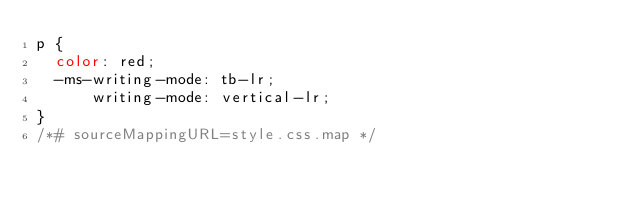Convert code to text. <code><loc_0><loc_0><loc_500><loc_500><_CSS_>p {
  color: red;
  -ms-writing-mode: tb-lr;
      writing-mode: vertical-lr;
}
/*# sourceMappingURL=style.css.map */</code> 